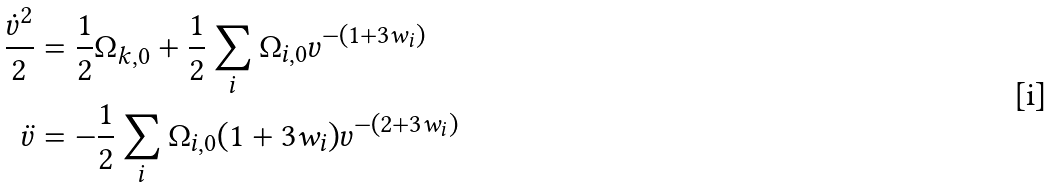Convert formula to latex. <formula><loc_0><loc_0><loc_500><loc_500>\frac { \dot { v } ^ { 2 } } { 2 } & = \frac { 1 } { 2 } \Omega _ { k , 0 } + \frac { 1 } { 2 } \sum _ { i } \Omega _ { i , 0 } v ^ { - ( 1 + 3 w _ { i } ) } \\ \ddot { v } & = - \frac { 1 } { 2 } \sum _ { i } \Omega _ { i , 0 } ( 1 + 3 w _ { i } ) v ^ { - ( 2 + 3 w _ { i } ) }</formula> 